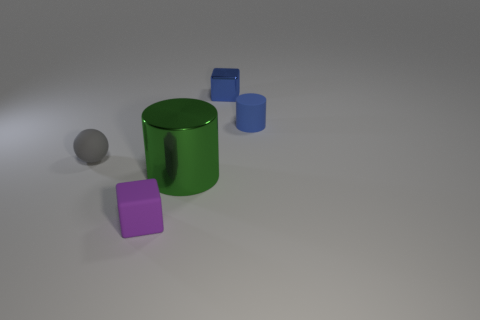There is a purple object that is the same size as the blue cylinder; what is its material? The purple object, appearing to have a matte surface akin to the blue cylinder nearby, is likely made of plastic, a common material for objects of this kind in this visual context. 